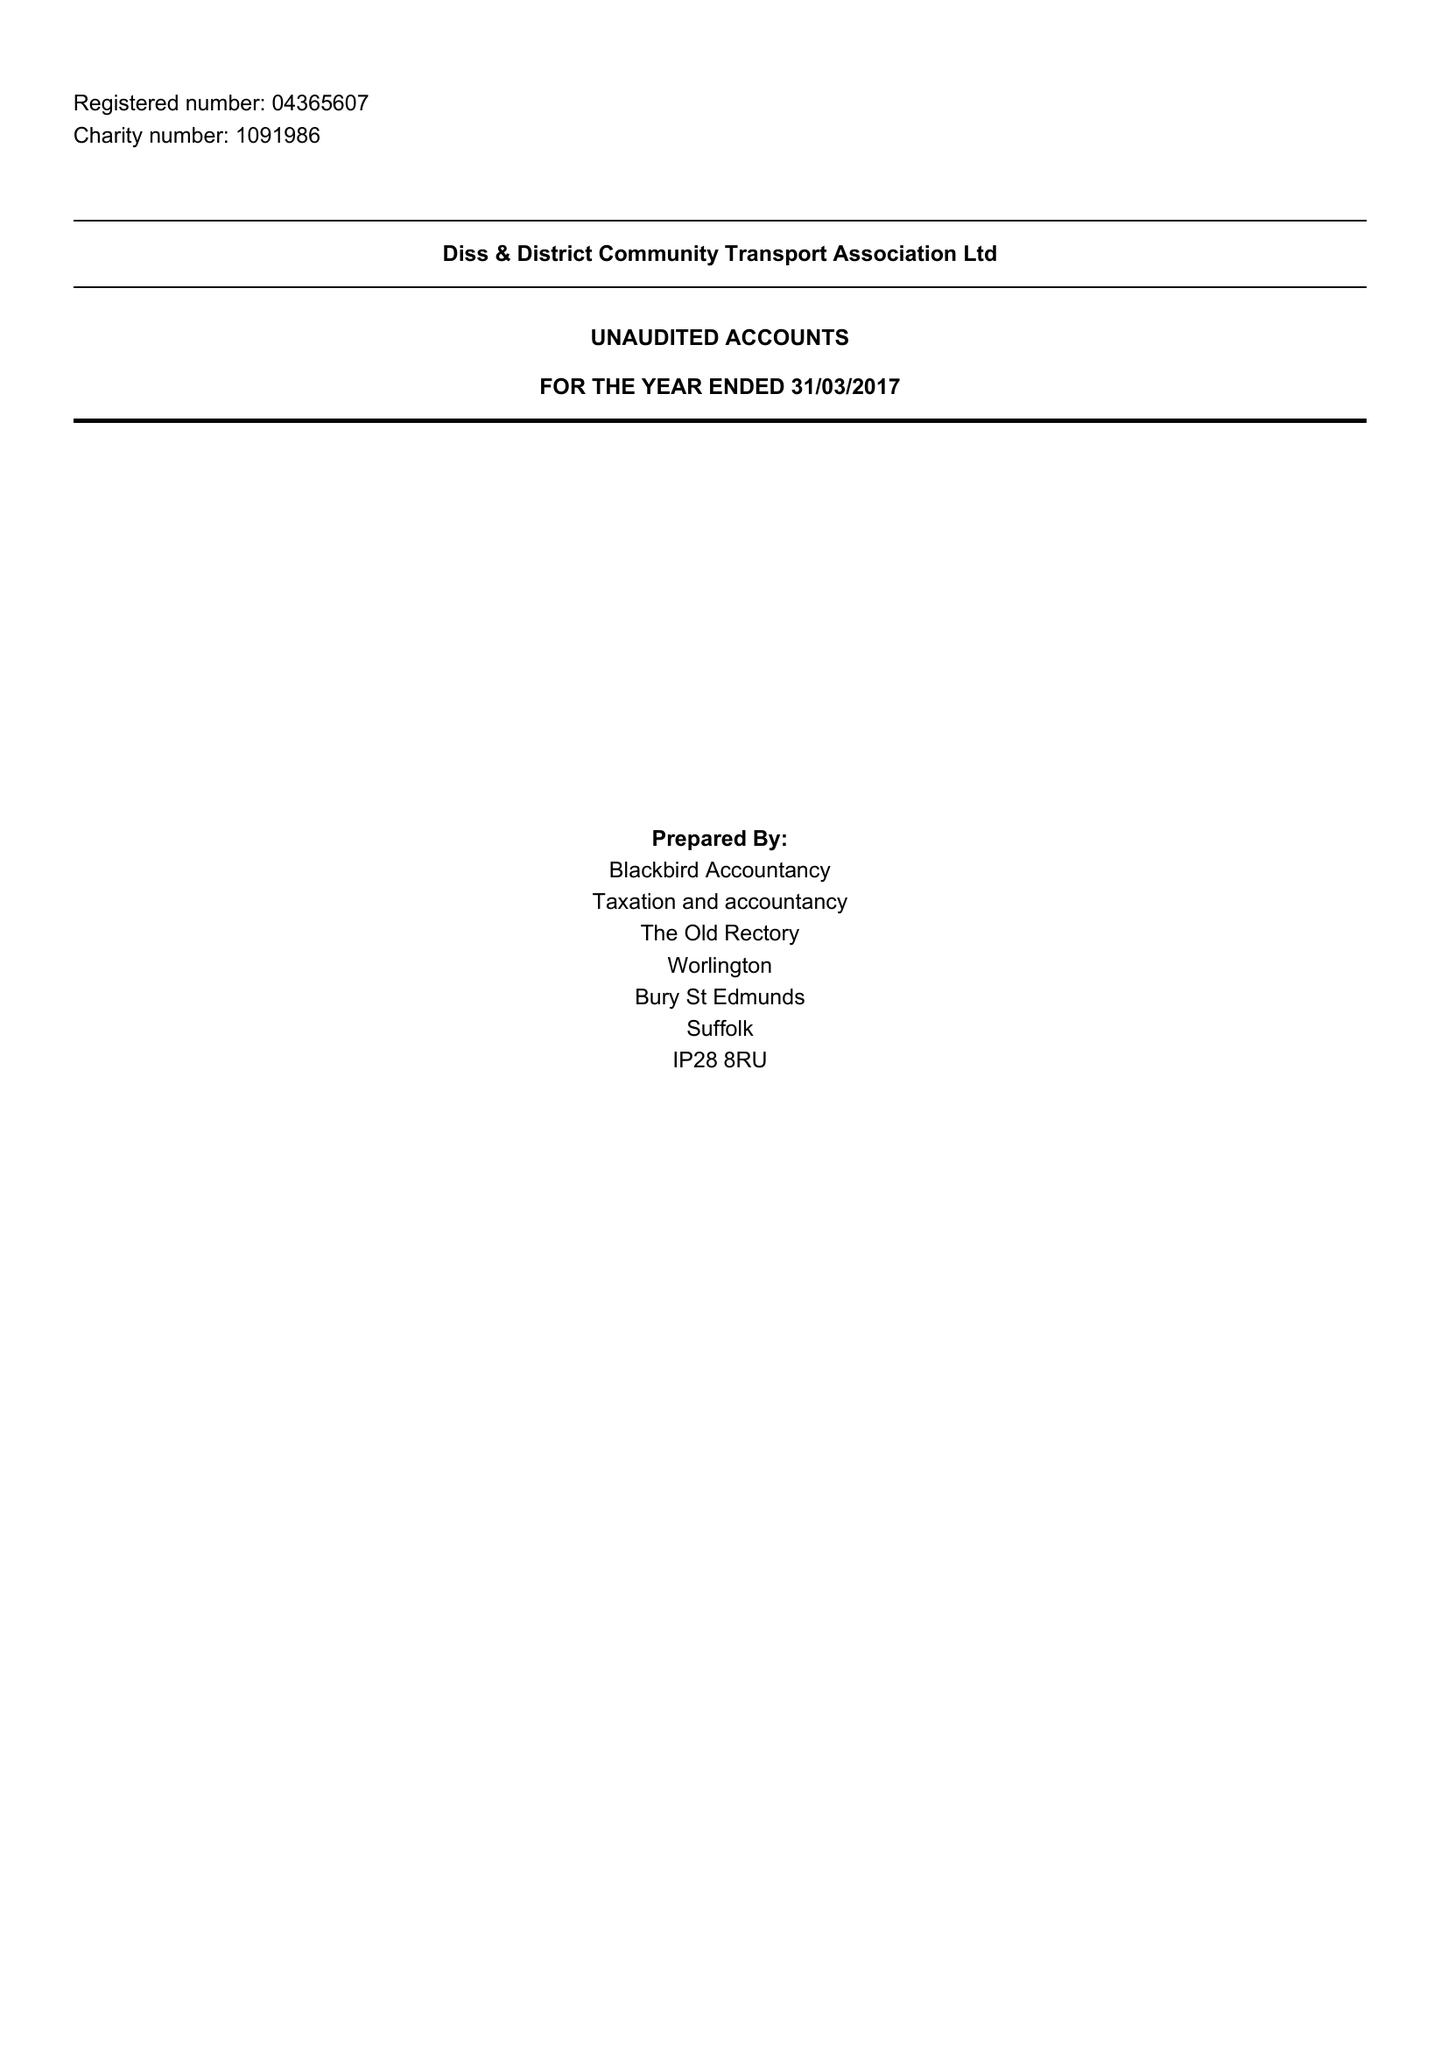What is the value for the address__post_town?
Answer the question using a single word or phrase. EYE 